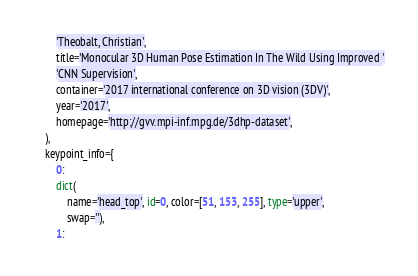Convert code to text. <code><loc_0><loc_0><loc_500><loc_500><_Python_>        'Theobalt, Christian',
        title='Monocular 3D Human Pose Estimation In The Wild Using Improved '
        'CNN Supervision',
        container='2017 international conference on 3D vision (3DV)',
        year='2017',
        homepage='http://gvv.mpi-inf.mpg.de/3dhp-dataset',
    ),
    keypoint_info={
        0:
        dict(
            name='head_top', id=0, color=[51, 153, 255], type='upper',
            swap=''),
        1:</code> 